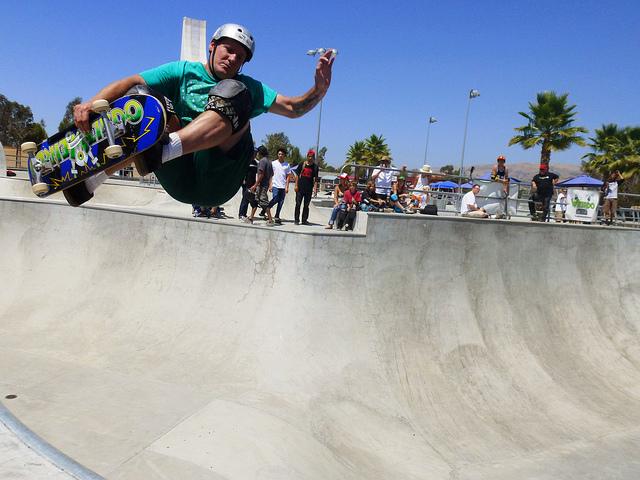Is there an audience?
Concise answer only. Yes. Is this a frontside air?
Short answer required. Yes. What color is the shirt?
Answer briefly. Green. Is the skateboarder wearing knee pads?
Quick response, please. Yes. What color is his skateboard?
Short answer required. Blue. Is the biker watching the skater's performance?
Be succinct. No. 